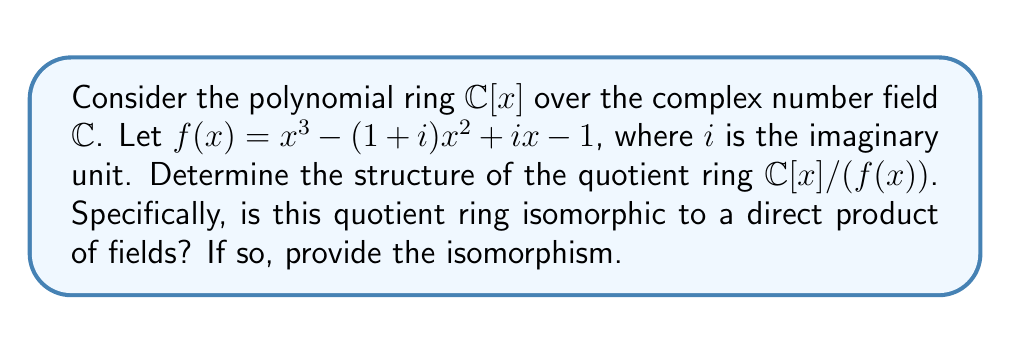Teach me how to tackle this problem. 1) First, we need to factor $f(x)$ over $\mathbb{C}$. Using the rational root theorem and complex number properties, we can find:

   $f(x) = (x-1)(x-i)(x+1-i)$

2) Since $f(x)$ factors into linear terms over $\mathbb{C}$, each factor corresponds to a maximal ideal in $\mathbb{C}[x]$:

   $M_1 = (x-1)$
   $M_2 = (x-i)$
   $M_3 = (x+1-i)$

3) By the Chinese Remainder Theorem for rings, we have:

   $\mathbb{C}[x]/(f(x)) \cong \mathbb{C}[x]/(x-1) \times \mathbb{C}[x]/(x-i) \times \mathbb{C}[x]/(x+1-i)$

4) Each quotient ring $\mathbb{C}[x]/(x-a)$ is isomorphic to $\mathbb{C}$ via the evaluation homomorphism $\phi_a: p(x) \mapsto p(a)$

5) Therefore, we have the isomorphism:

   $\mathbb{C}[x]/(f(x)) \cong \mathbb{C} \times \mathbb{C} \times \mathbb{C}$

6) The explicit isomorphism $\phi: \mathbb{C}[x]/(f(x)) \to \mathbb{C} \times \mathbb{C} \times \mathbb{C}$ is given by:

   $\phi(p(x) + (f(x))) = (p(1), p(i), p(-1+i))$

   for any polynomial $p(x) \in \mathbb{C}[x]$.
Answer: $\mathbb{C}[x]/(f(x)) \cong \mathbb{C} \times \mathbb{C} \times \mathbb{C}$ 